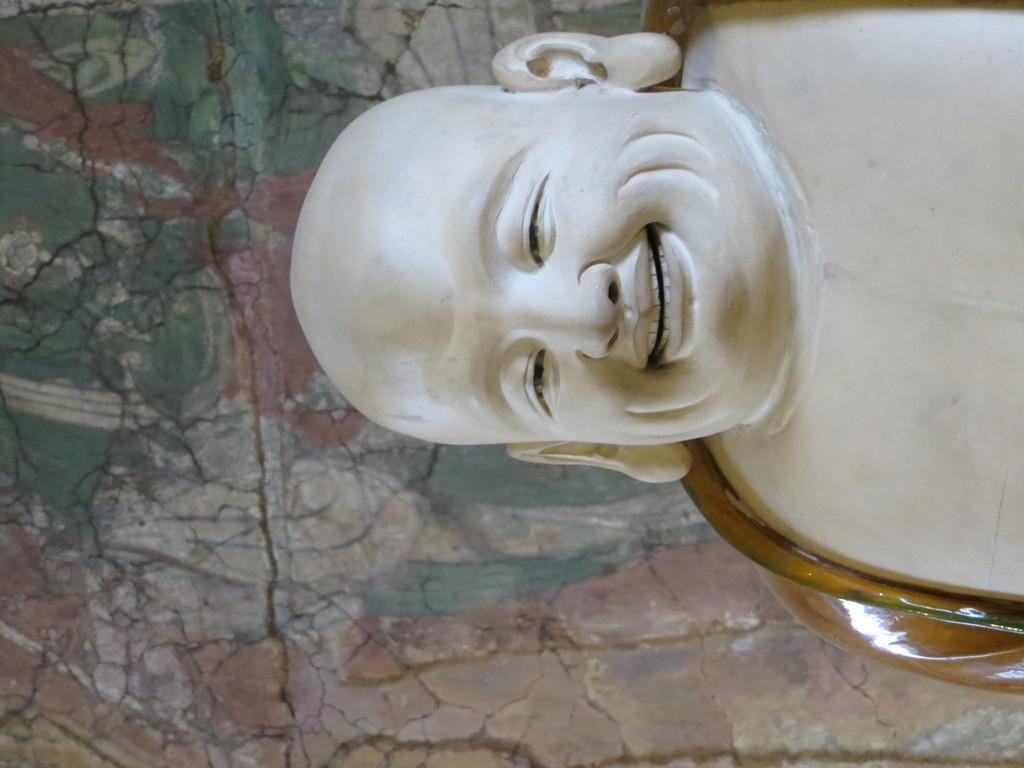What figure can be seen on the right side of the image? There is a laughing buddha on the right side of the image. What type of structure is visible in the image? There is a wall in the image. Can you see any grapes growing on the wall in the image? There are no grapes visible in the image, and the wall does not appear to be a vineyard or any other location where grapes would typically grow. 